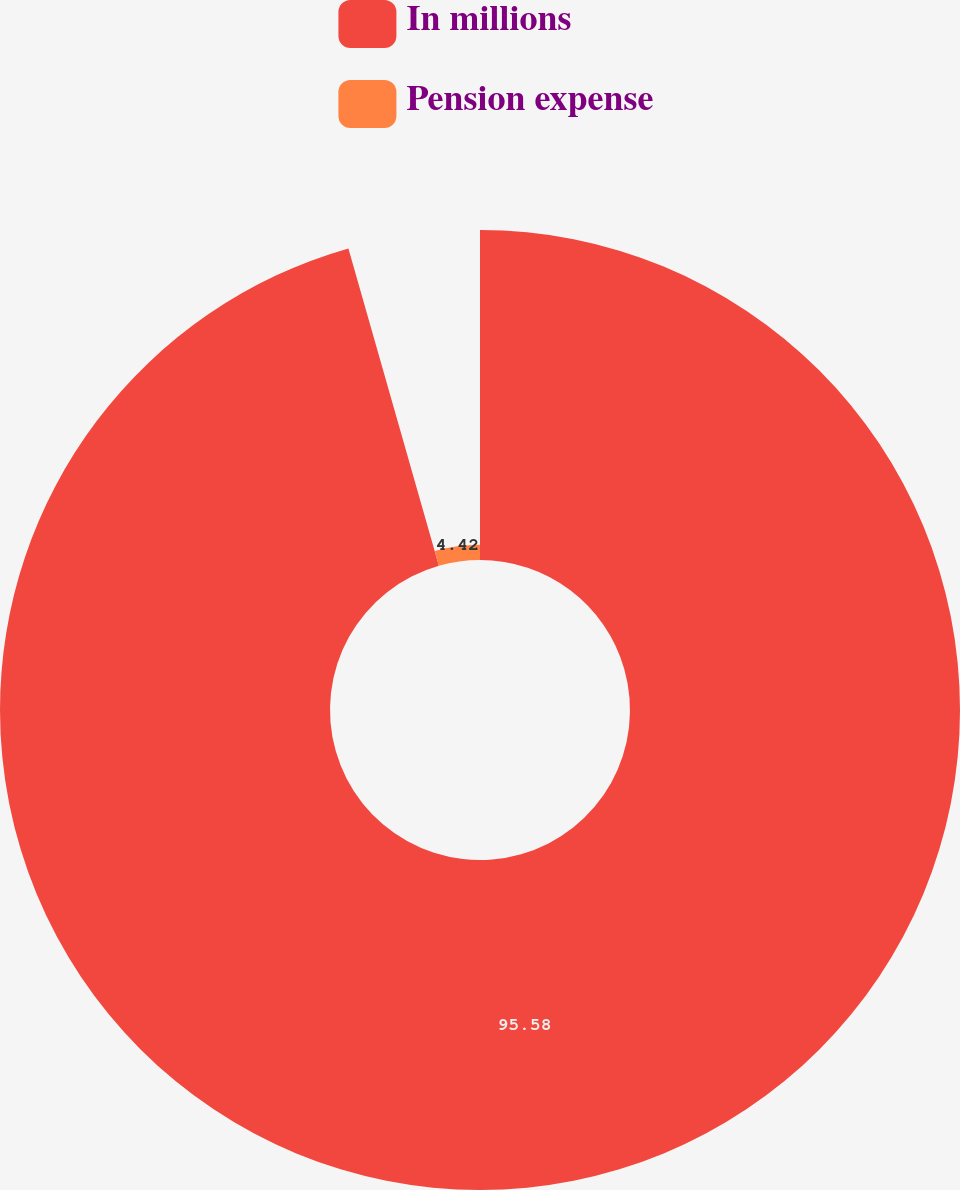Convert chart. <chart><loc_0><loc_0><loc_500><loc_500><pie_chart><fcel>In millions<fcel>Pension expense<nl><fcel>95.58%<fcel>4.42%<nl></chart> 